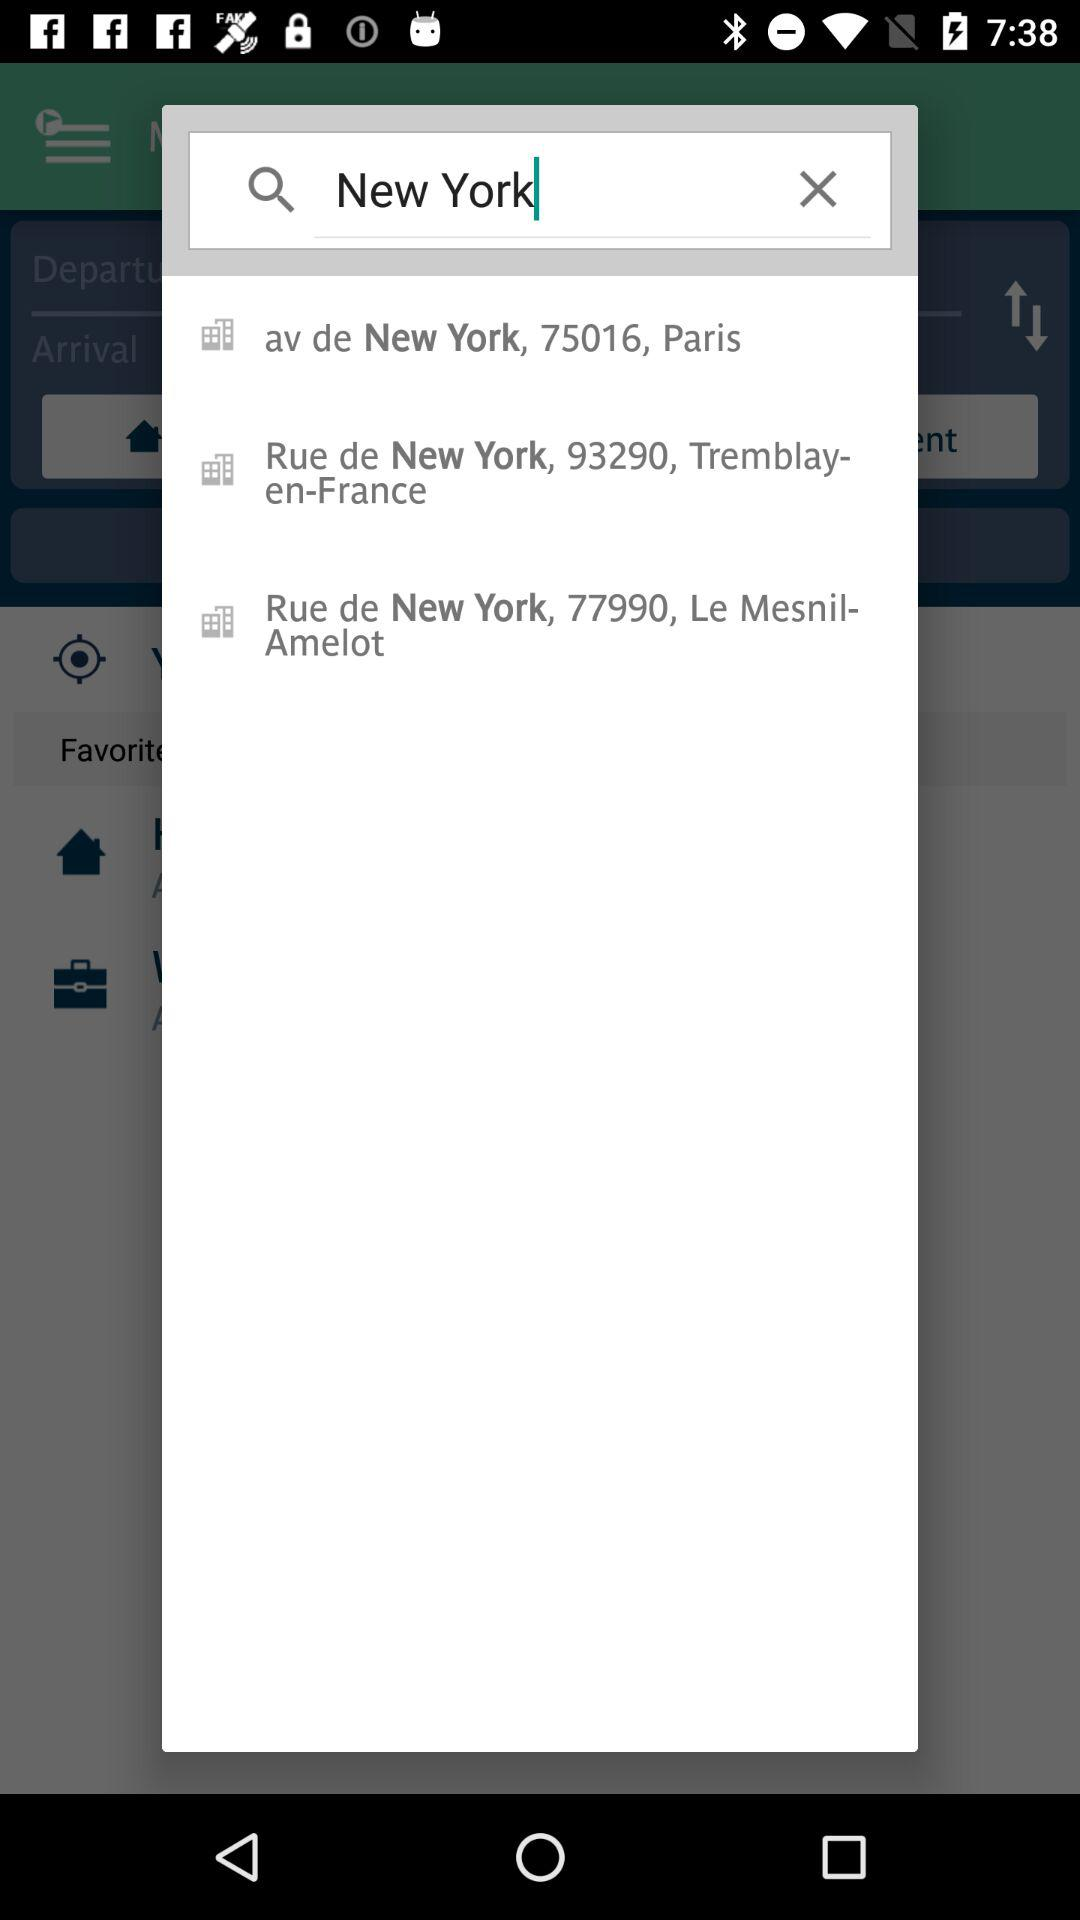For what location is the person searching? A person is searching for New York. 